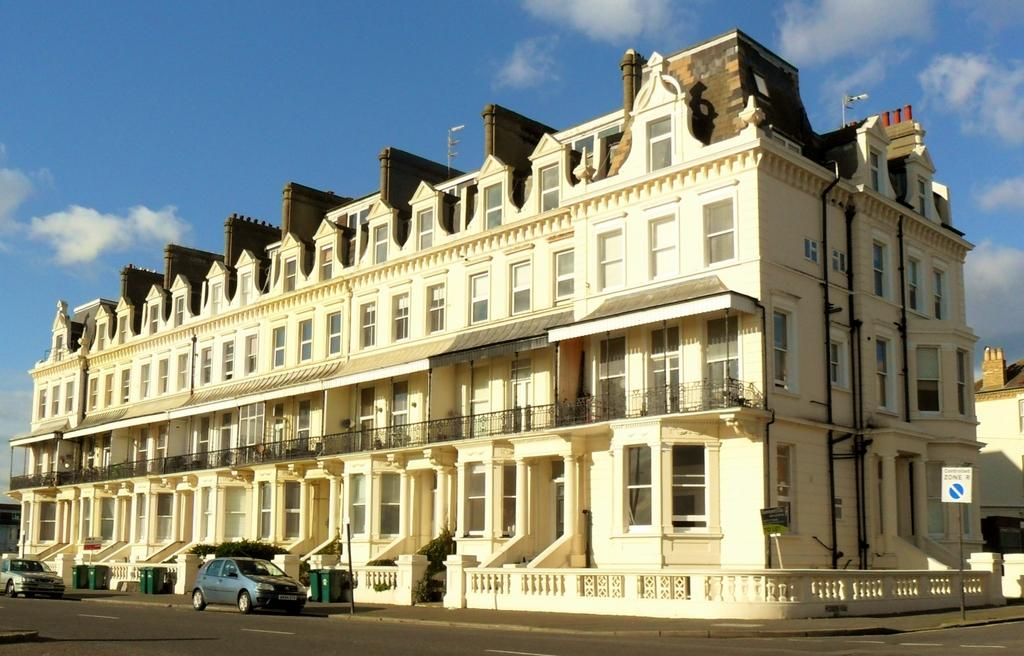What type of structure is visible in the image? There is a building in the image. What can be seen in front of the building? Many vehicles are present on the road in front of the building. What color is the sky in the image? The sky is blue in the image. Can you see any worms crawling on the building in the image? No, there are no worms visible in the image. 